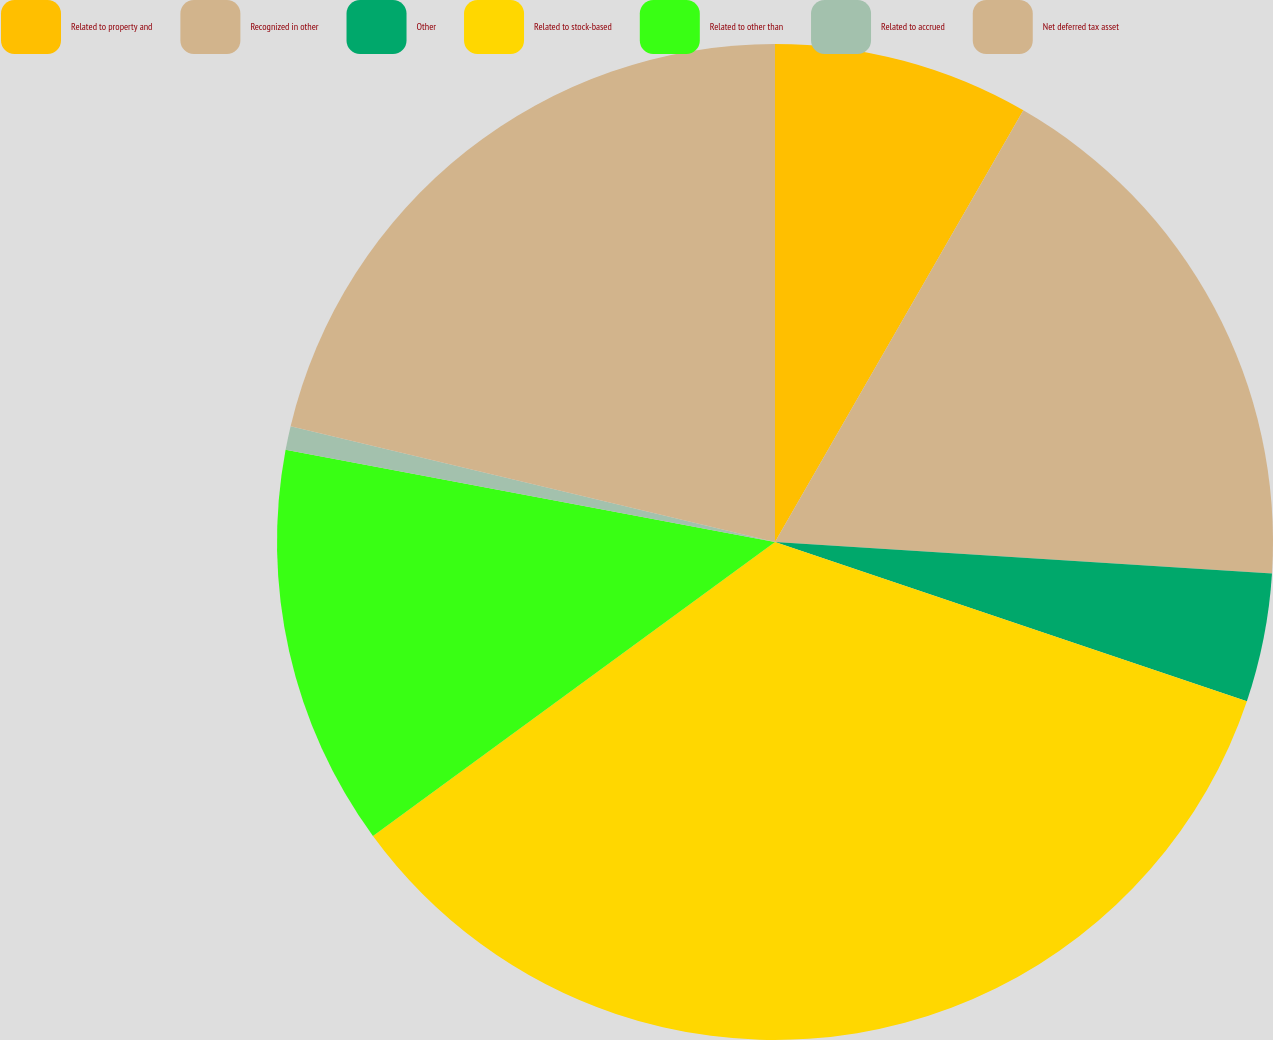<chart> <loc_0><loc_0><loc_500><loc_500><pie_chart><fcel>Related to property and<fcel>Recognized in other<fcel>Other<fcel>Related to stock-based<fcel>Related to other than<fcel>Related to accrued<fcel>Net deferred tax asset<nl><fcel>8.31%<fcel>17.7%<fcel>4.17%<fcel>34.78%<fcel>13.01%<fcel>0.77%<fcel>21.27%<nl></chart> 